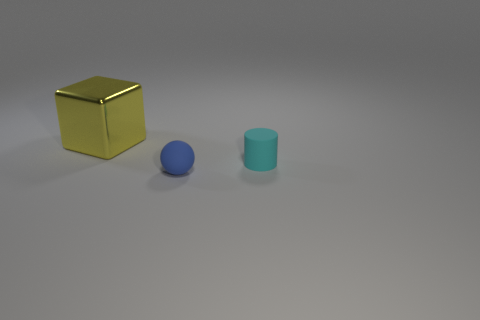There is a rubber cylinder that is right of the tiny blue rubber sphere; what color is it?
Ensure brevity in your answer.  Cyan. How many things are things in front of the big metal cube or objects that are behind the tiny blue sphere?
Ensure brevity in your answer.  3. How many other matte things are the same shape as the tiny cyan object?
Provide a short and direct response. 0. There is a matte ball that is the same size as the cyan cylinder; what color is it?
Offer a very short reply. Blue. What is the color of the tiny object behind the matte thing that is in front of the rubber object that is behind the blue thing?
Offer a terse response. Cyan. Do the blue thing and the object that is behind the cyan matte object have the same size?
Your response must be concise. No. How many objects are either large blocks or tiny cyan objects?
Give a very brief answer. 2. Are there any tiny blue spheres made of the same material as the cyan cylinder?
Your answer should be very brief. Yes. There is a matte thing in front of the thing that is to the right of the small blue ball; what color is it?
Provide a succinct answer. Blue. Do the cyan matte cylinder and the sphere have the same size?
Provide a succinct answer. Yes. 